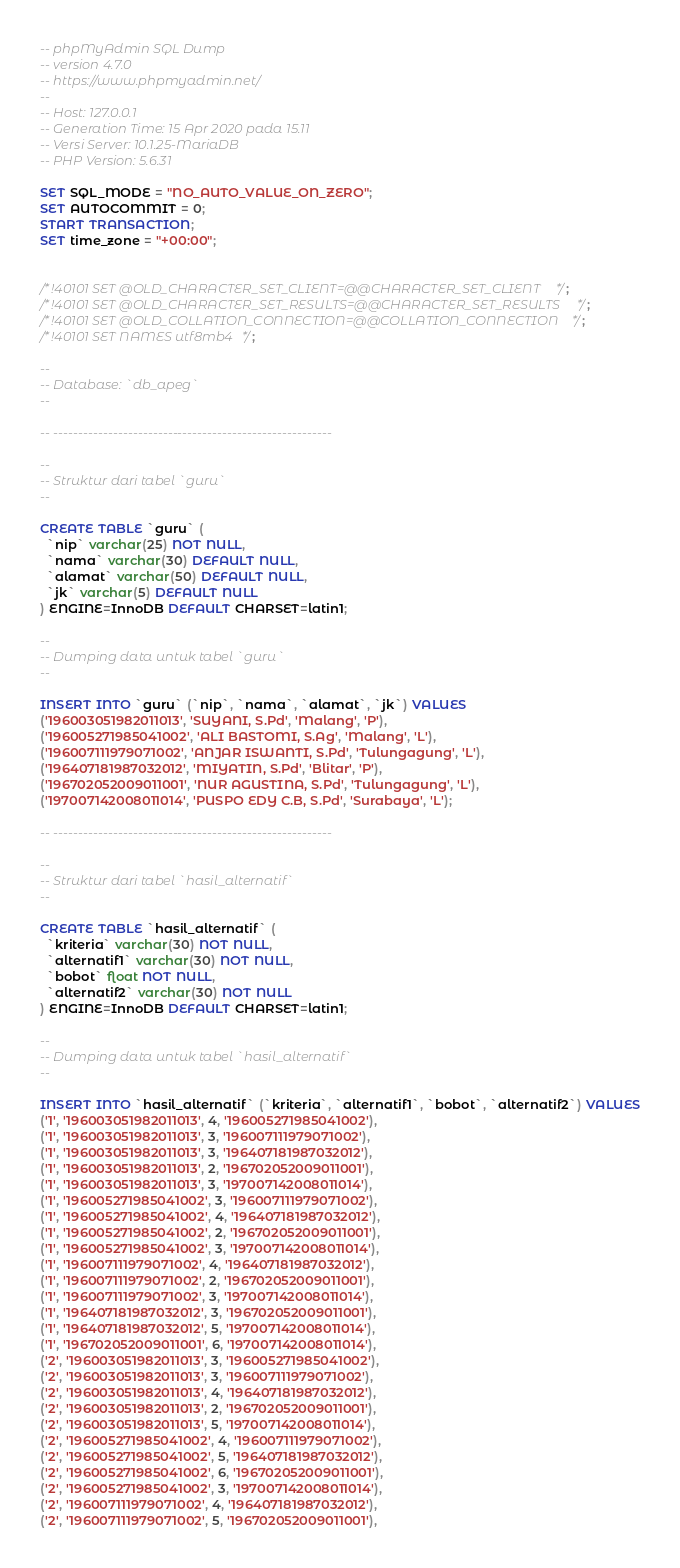Convert code to text. <code><loc_0><loc_0><loc_500><loc_500><_SQL_>-- phpMyAdmin SQL Dump
-- version 4.7.0
-- https://www.phpmyadmin.net/
--
-- Host: 127.0.0.1
-- Generation Time: 15 Apr 2020 pada 15.11
-- Versi Server: 10.1.25-MariaDB
-- PHP Version: 5.6.31

SET SQL_MODE = "NO_AUTO_VALUE_ON_ZERO";
SET AUTOCOMMIT = 0;
START TRANSACTION;
SET time_zone = "+00:00";


/*!40101 SET @OLD_CHARACTER_SET_CLIENT=@@CHARACTER_SET_CLIENT */;
/*!40101 SET @OLD_CHARACTER_SET_RESULTS=@@CHARACTER_SET_RESULTS */;
/*!40101 SET @OLD_COLLATION_CONNECTION=@@COLLATION_CONNECTION */;
/*!40101 SET NAMES utf8mb4 */;

--
-- Database: `db_apeg`
--

-- --------------------------------------------------------

--
-- Struktur dari tabel `guru`
--

CREATE TABLE `guru` (
  `nip` varchar(25) NOT NULL,
  `nama` varchar(30) DEFAULT NULL,
  `alamat` varchar(50) DEFAULT NULL,
  `jk` varchar(5) DEFAULT NULL
) ENGINE=InnoDB DEFAULT CHARSET=latin1;

--
-- Dumping data untuk tabel `guru`
--

INSERT INTO `guru` (`nip`, `nama`, `alamat`, `jk`) VALUES
('196003051982011013', 'SUYANI, S.Pd', 'Malang', 'P'),
('196005271985041002', 'ALI BASTOMI, S.Ag', 'Malang', 'L'),
('196007111979071002', 'ANJAR ISWANTI, S.Pd', 'Tulungagung', 'L'),
('196407181987032012', 'MIYATIN, S.Pd', 'Blitar', 'P'),
('196702052009011001', 'NUR AGUSTINA, S.Pd', 'Tulungagung', 'L'),
('197007142008011014', 'PUSPO EDY C.B, S.Pd', 'Surabaya', 'L');

-- --------------------------------------------------------

--
-- Struktur dari tabel `hasil_alternatif`
--

CREATE TABLE `hasil_alternatif` (
  `kriteria` varchar(30) NOT NULL,
  `alternatif1` varchar(30) NOT NULL,
  `bobot` float NOT NULL,
  `alternatif2` varchar(30) NOT NULL
) ENGINE=InnoDB DEFAULT CHARSET=latin1;

--
-- Dumping data untuk tabel `hasil_alternatif`
--

INSERT INTO `hasil_alternatif` (`kriteria`, `alternatif1`, `bobot`, `alternatif2`) VALUES
('1', '196003051982011013', 4, '196005271985041002'),
('1', '196003051982011013', 3, '196007111979071002'),
('1', '196003051982011013', 3, '196407181987032012'),
('1', '196003051982011013', 2, '196702052009011001'),
('1', '196003051982011013', 3, '197007142008011014'),
('1', '196005271985041002', 3, '196007111979071002'),
('1', '196005271985041002', 4, '196407181987032012'),
('1', '196005271985041002', 2, '196702052009011001'),
('1', '196005271985041002', 3, '197007142008011014'),
('1', '196007111979071002', 4, '196407181987032012'),
('1', '196007111979071002', 2, '196702052009011001'),
('1', '196007111979071002', 3, '197007142008011014'),
('1', '196407181987032012', 3, '196702052009011001'),
('1', '196407181987032012', 5, '197007142008011014'),
('1', '196702052009011001', 6, '197007142008011014'),
('2', '196003051982011013', 3, '196005271985041002'),
('2', '196003051982011013', 3, '196007111979071002'),
('2', '196003051982011013', 4, '196407181987032012'),
('2', '196003051982011013', 2, '196702052009011001'),
('2', '196003051982011013', 5, '197007142008011014'),
('2', '196005271985041002', 4, '196007111979071002'),
('2', '196005271985041002', 5, '196407181987032012'),
('2', '196005271985041002', 6, '196702052009011001'),
('2', '196005271985041002', 3, '197007142008011014'),
('2', '196007111979071002', 4, '196407181987032012'),
('2', '196007111979071002', 5, '196702052009011001'),</code> 